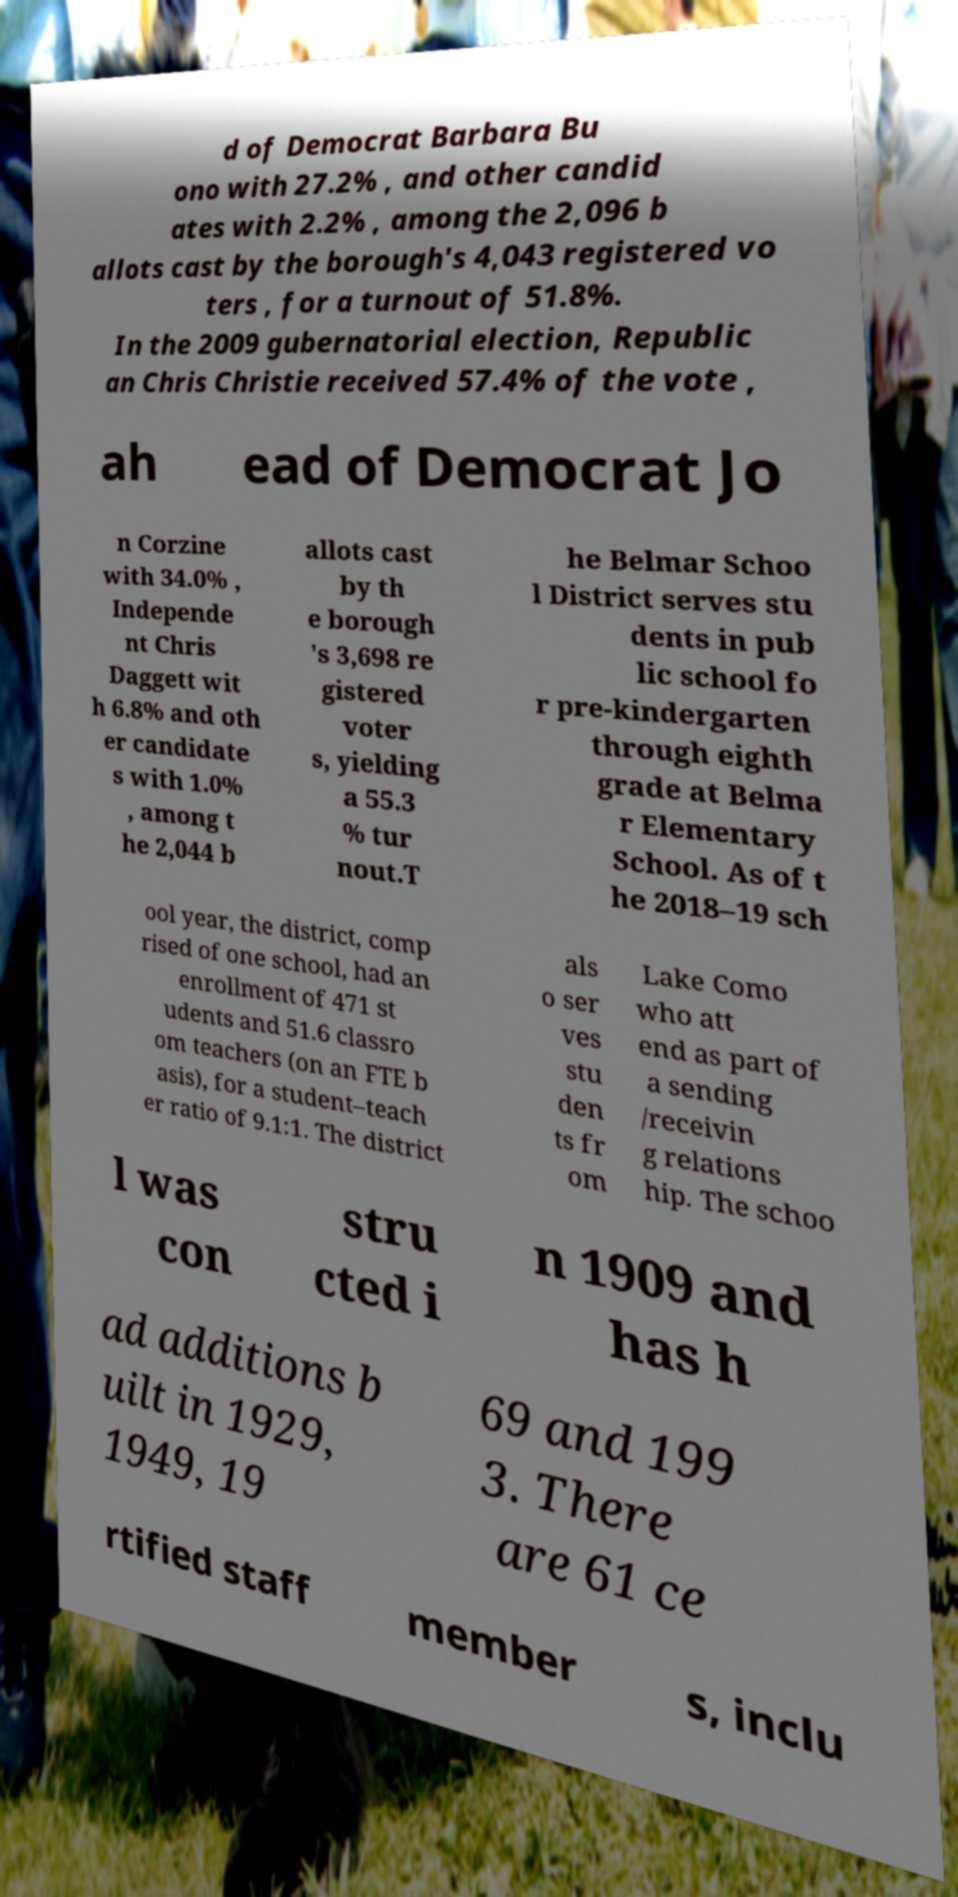Can you accurately transcribe the text from the provided image for me? d of Democrat Barbara Bu ono with 27.2% , and other candid ates with 2.2% , among the 2,096 b allots cast by the borough's 4,043 registered vo ters , for a turnout of 51.8%. In the 2009 gubernatorial election, Republic an Chris Christie received 57.4% of the vote , ah ead of Democrat Jo n Corzine with 34.0% , Independe nt Chris Daggett wit h 6.8% and oth er candidate s with 1.0% , among t he 2,044 b allots cast by th e borough 's 3,698 re gistered voter s, yielding a 55.3 % tur nout.T he Belmar Schoo l District serves stu dents in pub lic school fo r pre-kindergarten through eighth grade at Belma r Elementary School. As of t he 2018–19 sch ool year, the district, comp rised of one school, had an enrollment of 471 st udents and 51.6 classro om teachers (on an FTE b asis), for a student–teach er ratio of 9.1:1. The district als o ser ves stu den ts fr om Lake Como who att end as part of a sending /receivin g relations hip. The schoo l was con stru cted i n 1909 and has h ad additions b uilt in 1929, 1949, 19 69 and 199 3. There are 61 ce rtified staff member s, inclu 